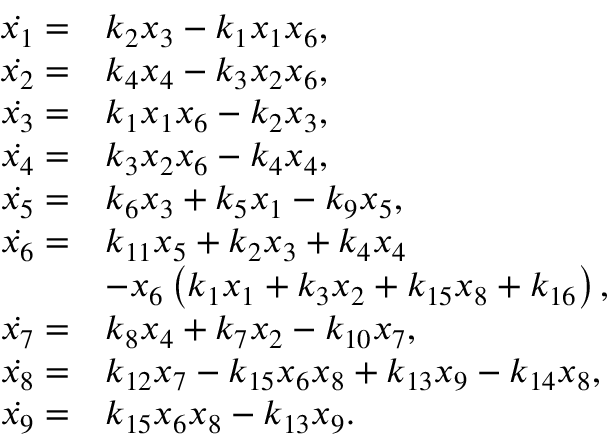Convert formula to latex. <formula><loc_0><loc_0><loc_500><loc_500>\begin{array} { r l } { \ D o t { x _ { 1 } } = } & { k _ { 2 } x _ { 3 } - k _ { 1 } x _ { 1 } x _ { 6 } , } \\ { \ D o t { x _ { 2 } } = } & { k _ { 4 } x _ { 4 } - k _ { 3 } x _ { 2 } x _ { 6 } , } \\ { \ D o t { x _ { 3 } } = } & { k _ { 1 } x _ { 1 } x _ { 6 } - k _ { 2 } x _ { 3 } , } \\ { \ D o t { x _ { 4 } } = } & { k _ { 3 } x _ { 2 } x _ { 6 } - k _ { 4 } x _ { 4 } , } \\ { \ D o t { x _ { 5 } } = } & { k _ { 6 } x _ { 3 } + k _ { 5 } x _ { 1 } - k _ { 9 } x _ { 5 } , } \\ { \ D o t { x _ { 6 } } = } & { k _ { 1 1 } x _ { 5 } + k _ { 2 } x _ { 3 } + k _ { 4 } x _ { 4 } } \\ & { - x _ { 6 } \left ( k _ { 1 } x _ { 1 } + k _ { 3 } x _ { 2 } + k _ { 1 5 } x _ { 8 } + k _ { 1 6 } \right ) , } \\ { \ D o t { x _ { 7 } } = } & { k _ { 8 } x _ { 4 } + k _ { 7 } x _ { 2 } - k _ { 1 0 } x _ { 7 } , } \\ { \ D o t { x _ { 8 } } = } & { k _ { 1 2 } x _ { 7 } - k _ { 1 5 } x _ { 6 } x _ { 8 } + k _ { 1 3 } x _ { 9 } - k _ { 1 4 } x _ { 8 } , } \\ { \ D o t { x _ { 9 } } = } & { k _ { 1 5 } x _ { 6 } x _ { 8 } - k _ { 1 3 } x _ { 9 } . } \end{array}</formula> 